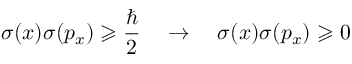<formula> <loc_0><loc_0><loc_500><loc_500>\sigma ( x ) \sigma ( p _ { x } ) \geqslant { \frac { } { 2 } } \quad \rightarrow \quad \sigma ( x ) \sigma ( p _ { x } ) \geqslant 0 \,</formula> 